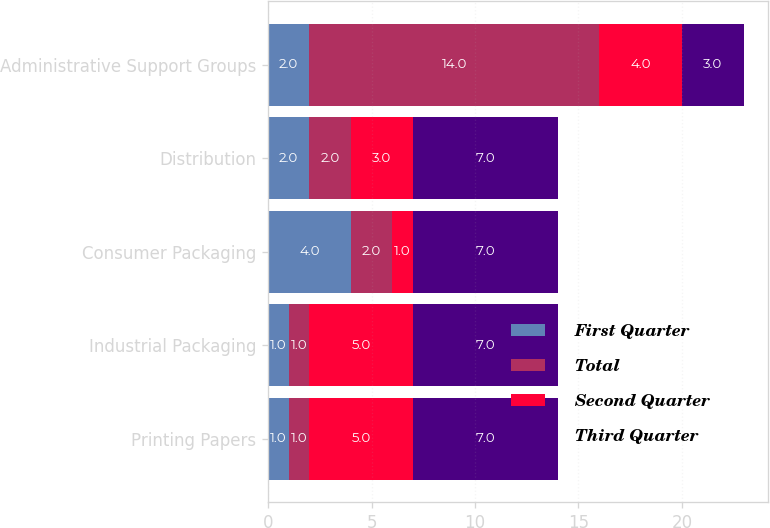<chart> <loc_0><loc_0><loc_500><loc_500><stacked_bar_chart><ecel><fcel>Printing Papers<fcel>Industrial Packaging<fcel>Consumer Packaging<fcel>Distribution<fcel>Administrative Support Groups<nl><fcel>First Quarter<fcel>1<fcel>1<fcel>4<fcel>2<fcel>2<nl><fcel>Total<fcel>1<fcel>1<fcel>2<fcel>2<fcel>14<nl><fcel>Second Quarter<fcel>5<fcel>5<fcel>1<fcel>3<fcel>4<nl><fcel>Third Quarter<fcel>7<fcel>7<fcel>7<fcel>7<fcel>3<nl></chart> 